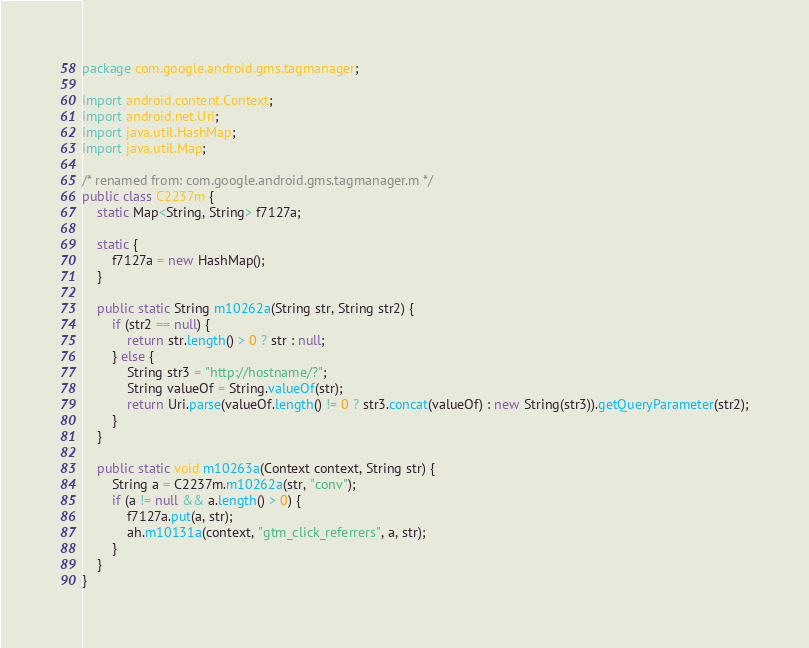<code> <loc_0><loc_0><loc_500><loc_500><_Java_>package com.google.android.gms.tagmanager;

import android.content.Context;
import android.net.Uri;
import java.util.HashMap;
import java.util.Map;

/* renamed from: com.google.android.gms.tagmanager.m */
public class C2237m {
    static Map<String, String> f7127a;

    static {
        f7127a = new HashMap();
    }

    public static String m10262a(String str, String str2) {
        if (str2 == null) {
            return str.length() > 0 ? str : null;
        } else {
            String str3 = "http://hostname/?";
            String valueOf = String.valueOf(str);
            return Uri.parse(valueOf.length() != 0 ? str3.concat(valueOf) : new String(str3)).getQueryParameter(str2);
        }
    }

    public static void m10263a(Context context, String str) {
        String a = C2237m.m10262a(str, "conv");
        if (a != null && a.length() > 0) {
            f7127a.put(a, str);
            ah.m10131a(context, "gtm_click_referrers", a, str);
        }
    }
}
</code> 